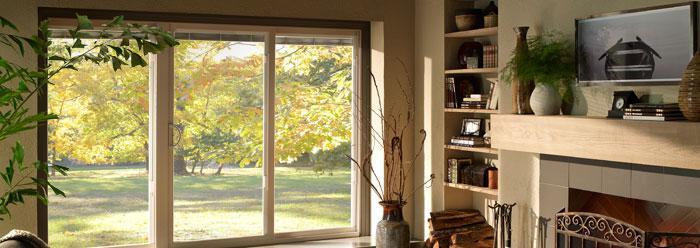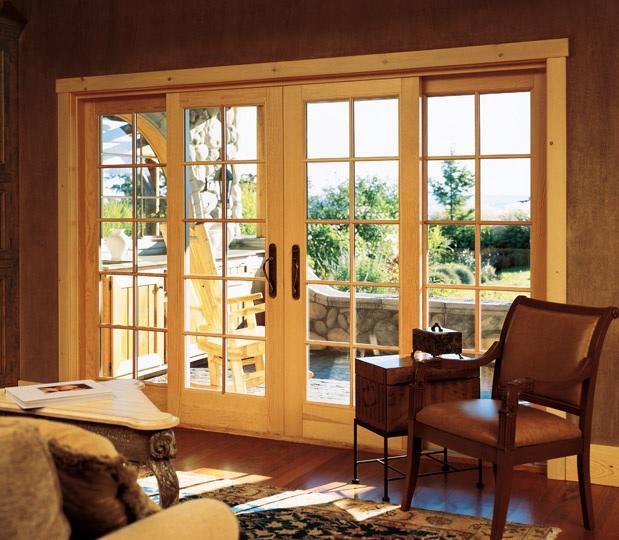The first image is the image on the left, the second image is the image on the right. Evaluate the accuracy of this statement regarding the images: "There is only one chair near the door in the right image.". Is it true? Answer yes or no. Yes. 